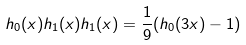<formula> <loc_0><loc_0><loc_500><loc_500>h _ { 0 } ( x ) h _ { 1 } ( x ) h _ { 1 } ( x ) = \frac { 1 } { 9 } ( h _ { 0 } ( 3 x ) - 1 )</formula> 